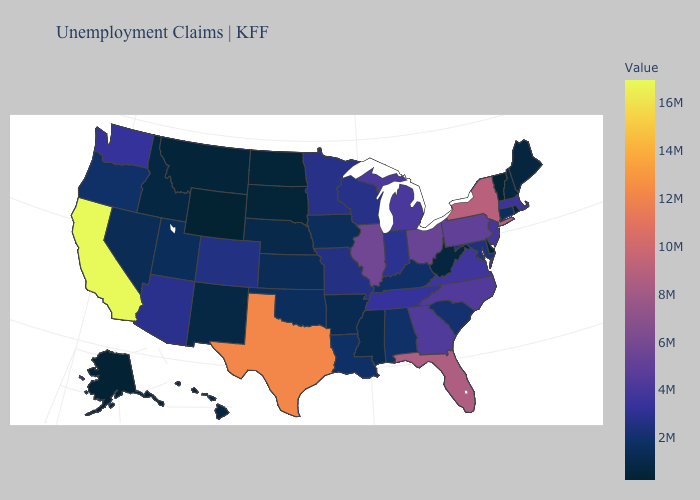Which states have the highest value in the USA?
Answer briefly. California. Among the states that border Mississippi , does Alabama have the highest value?
Keep it brief. No. Which states have the lowest value in the MidWest?
Short answer required. North Dakota. Among the states that border Montana , which have the highest value?
Write a very short answer. Idaho. Does California have the highest value in the West?
Short answer required. Yes. Among the states that border North Dakota , does Minnesota have the highest value?
Short answer required. Yes. 